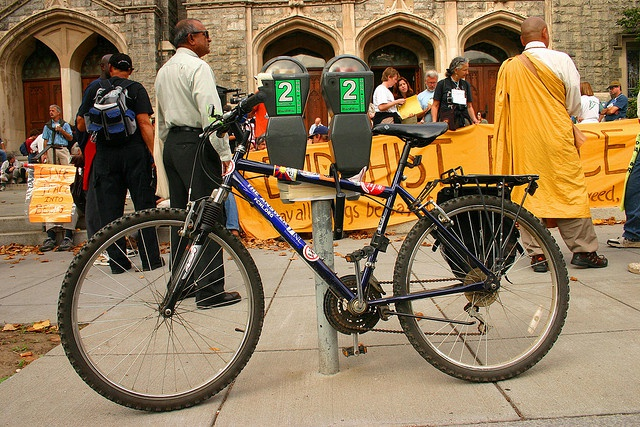Describe the objects in this image and their specific colors. I can see bicycle in gray, black, and tan tones, people in gray, orange, ivory, and gold tones, people in gray, black, beige, and darkgray tones, people in gray, black, maroon, and navy tones, and parking meter in gray, black, and darkgreen tones in this image. 